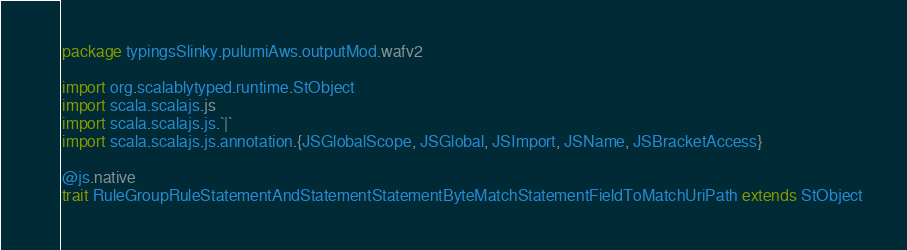Convert code to text. <code><loc_0><loc_0><loc_500><loc_500><_Scala_>package typingsSlinky.pulumiAws.outputMod.wafv2

import org.scalablytyped.runtime.StObject
import scala.scalajs.js
import scala.scalajs.js.`|`
import scala.scalajs.js.annotation.{JSGlobalScope, JSGlobal, JSImport, JSName, JSBracketAccess}

@js.native
trait RuleGroupRuleStatementAndStatementStatementByteMatchStatementFieldToMatchUriPath extends StObject
</code> 